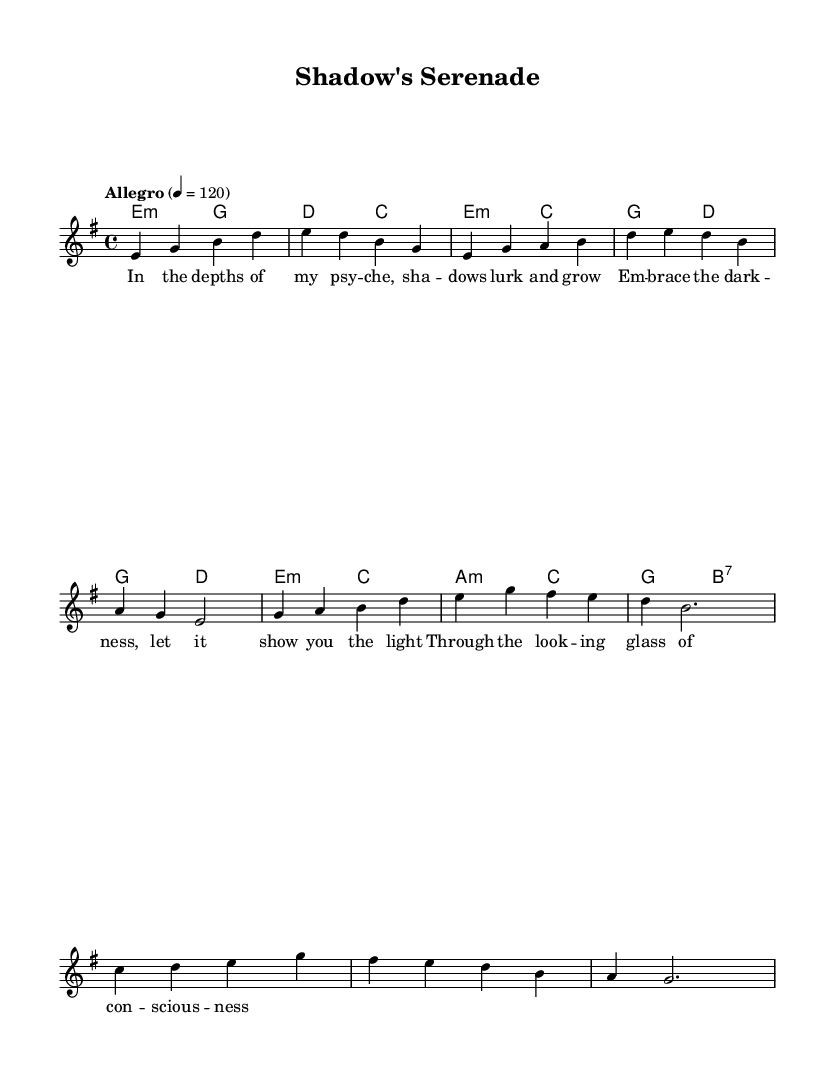What is the key signature of this music? The key signature displayed at the beginning of the score indicates E minor, which has one sharp (F#).
Answer: E minor What is the time signature of this music? The time signature shown in the score is 4/4, meaning there are four beats per measure and the quarter note gets one beat.
Answer: 4/4 What is the tempo marking of this piece? The tempo marking in the score indicates an allegro tempo, with a metronome marking of 120 beats per minute.
Answer: Allegro, 120 How many sections are identified in the score? The score consists of an Intro, Verse 1, Chorus, and Bridge, totaling four distinct sections.
Answer: Four What is the main theme of the lyrics in the Chorus? The Chorus expresses the idea of embracing darkness to reveal light, highlighting a theme of personal growth.
Answer: Embrace the darkness Which chord is used in the bridge of the music? The chords in the Bridge sequence include A minor and C major, meaning the dominant sound reflects tension and resolution.
Answer: A minor, C major What psychological archetype might the "shadows" in the lyrics represent? The "shadows" likely represent the Shadow archetype from Jungian psychology, symbolizing the repressed or unacknowledged aspects of the self.
Answer: Shadow archetype 